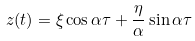<formula> <loc_0><loc_0><loc_500><loc_500>z ( t ) = \xi \cos \alpha \tau + \frac { \eta } { \alpha } \sin { \alpha \tau }</formula> 